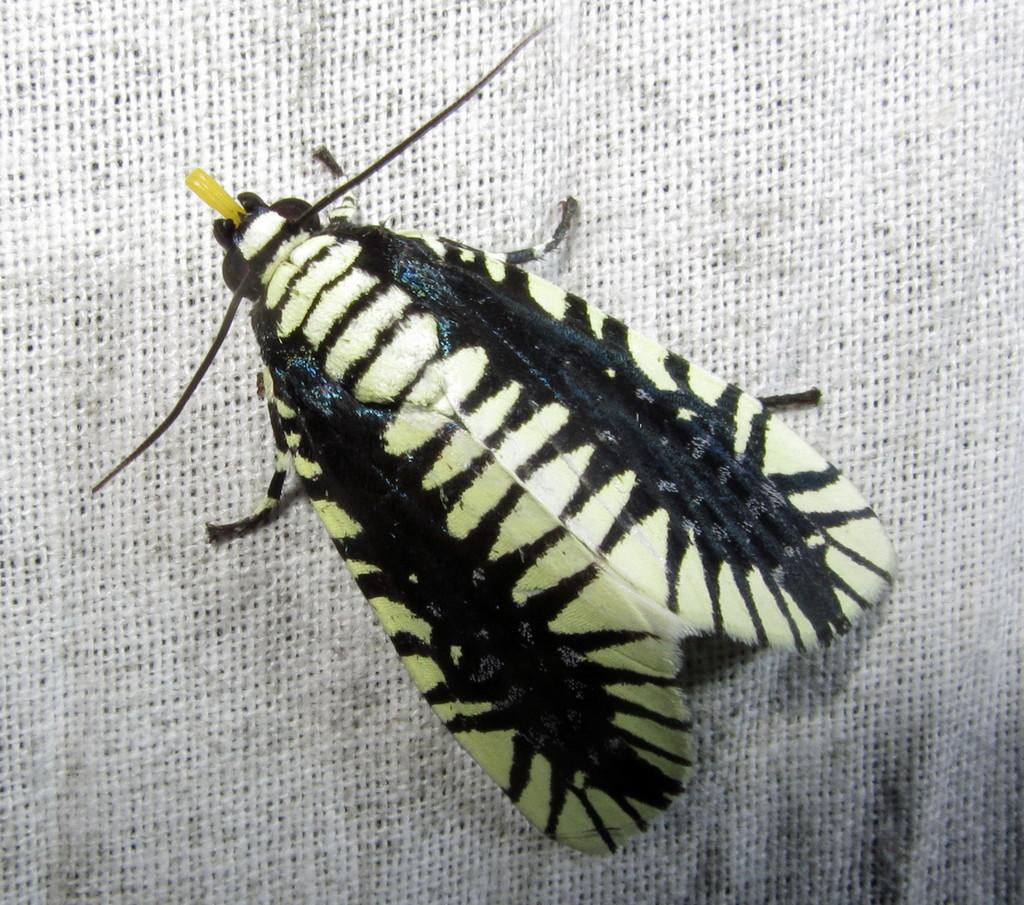What type of creature can be seen in the image? There is an insect in the image. Where is the insect located? The insect is on a surface. What type of bird can be seen flying over the park in the image? There is no bird or park present in the image; it only features an insect on a surface. 